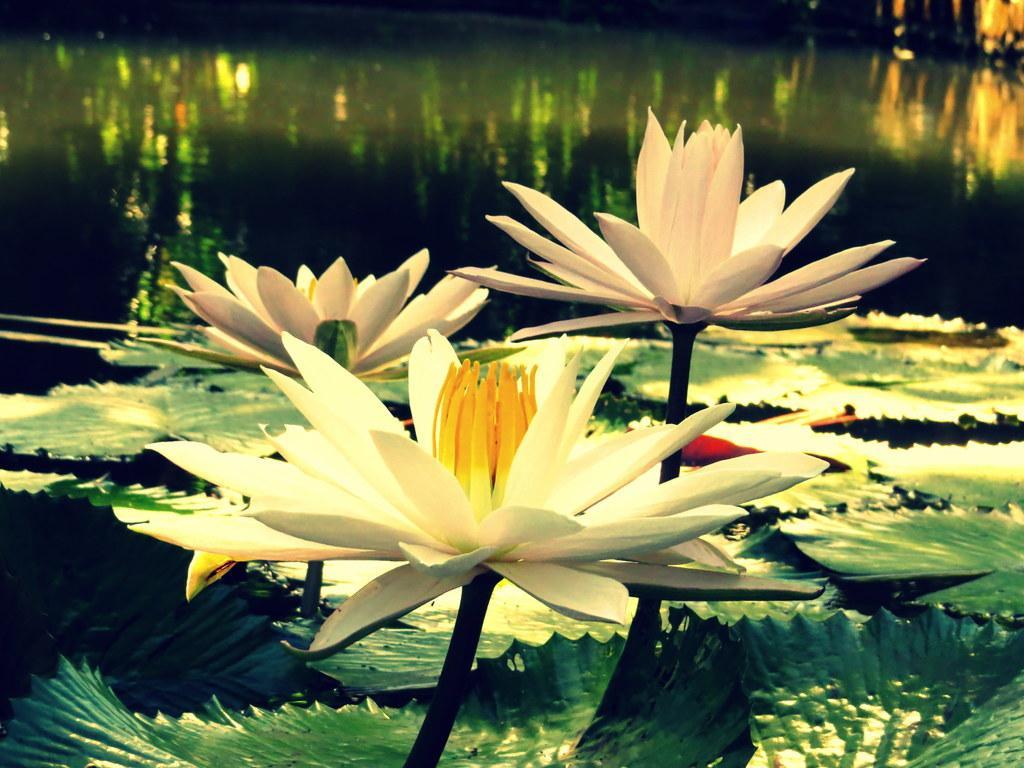Describe this image in one or two sentences. In this image few lotuses and few leaves are on the water. 